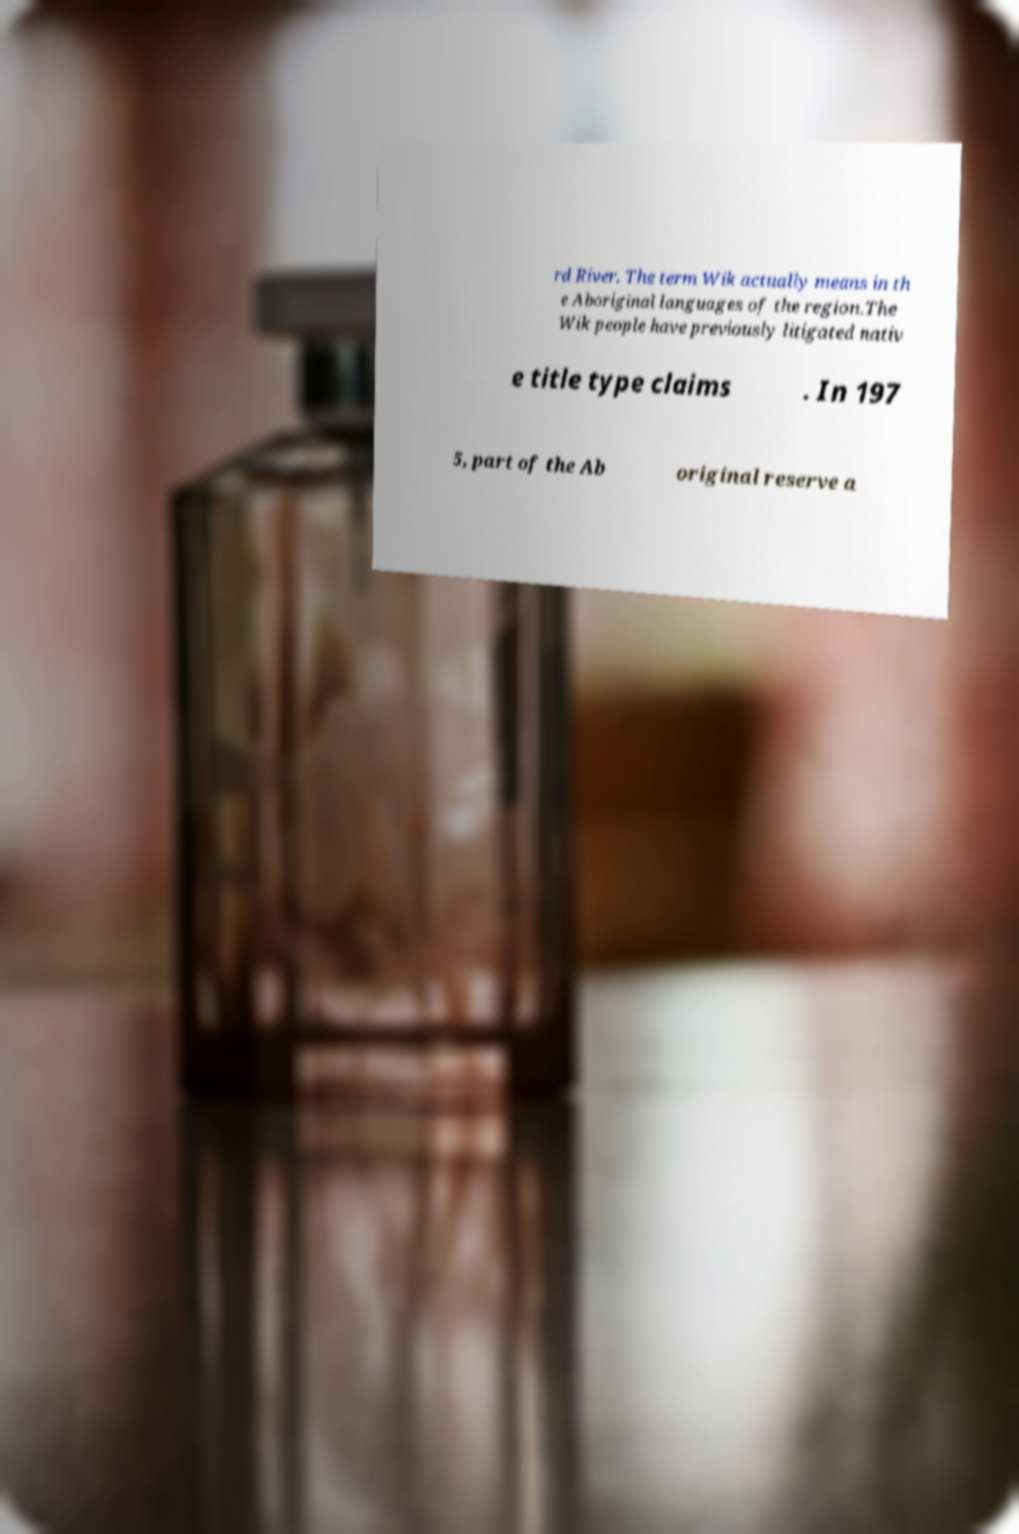Can you accurately transcribe the text from the provided image for me? rd River. The term Wik actually means in th e Aboriginal languages of the region.The Wik people have previously litigated nativ e title type claims . In 197 5, part of the Ab original reserve a 